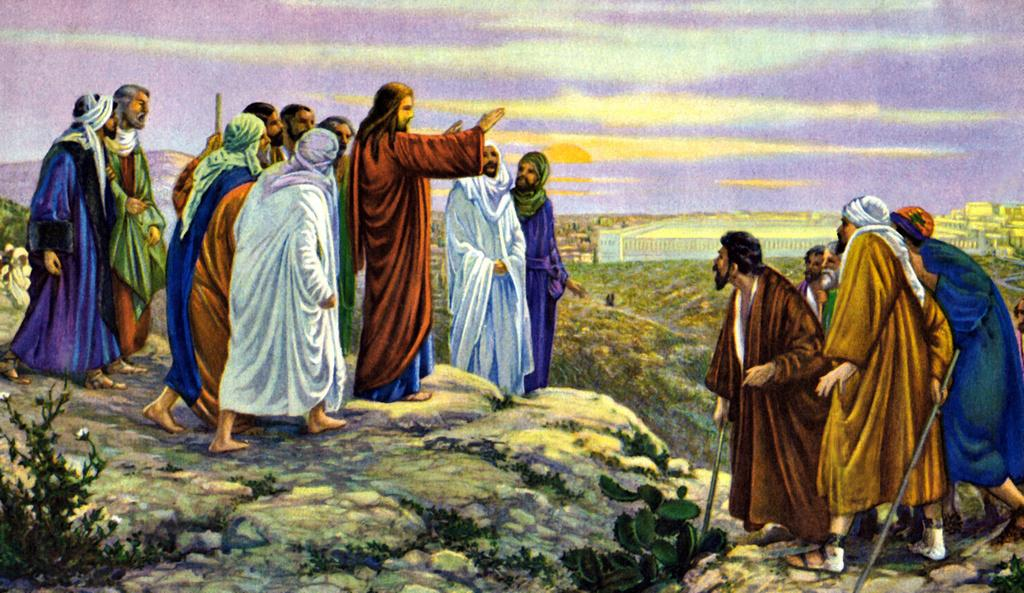What is depicted in the image? There is a painting of people in the image. What are the people in the painting doing? Some of the people in the painting are holding sticks. What can be seen in the background of the painting? There are plants, buildings, and the sky visible in the background of the painting. What type of stamp can be seen on the cow in the image? There is no cow or stamp present in the image; it features a painting of people. How many skateboards are visible in the image? There are no skateboards present in the image; it features a painting of people. 